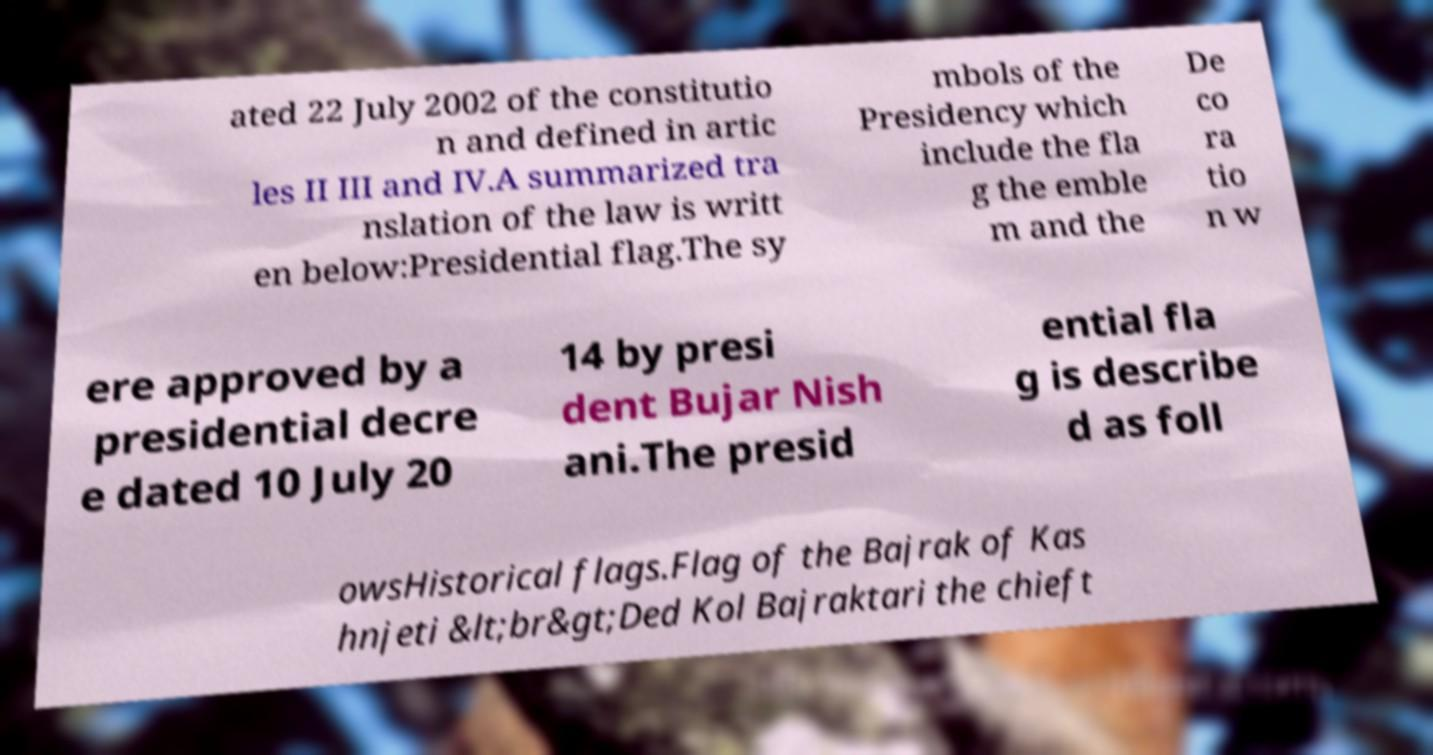There's text embedded in this image that I need extracted. Can you transcribe it verbatim? ated 22 July 2002 of the constitutio n and defined in artic les II III and IV.A summarized tra nslation of the law is writt en below:Presidential flag.The sy mbols of the Presidency which include the fla g the emble m and the De co ra tio n w ere approved by a presidential decre e dated 10 July 20 14 by presi dent Bujar Nish ani.The presid ential fla g is describe d as foll owsHistorical flags.Flag of the Bajrak of Kas hnjeti &lt;br&gt;Ded Kol Bajraktari the chieft 